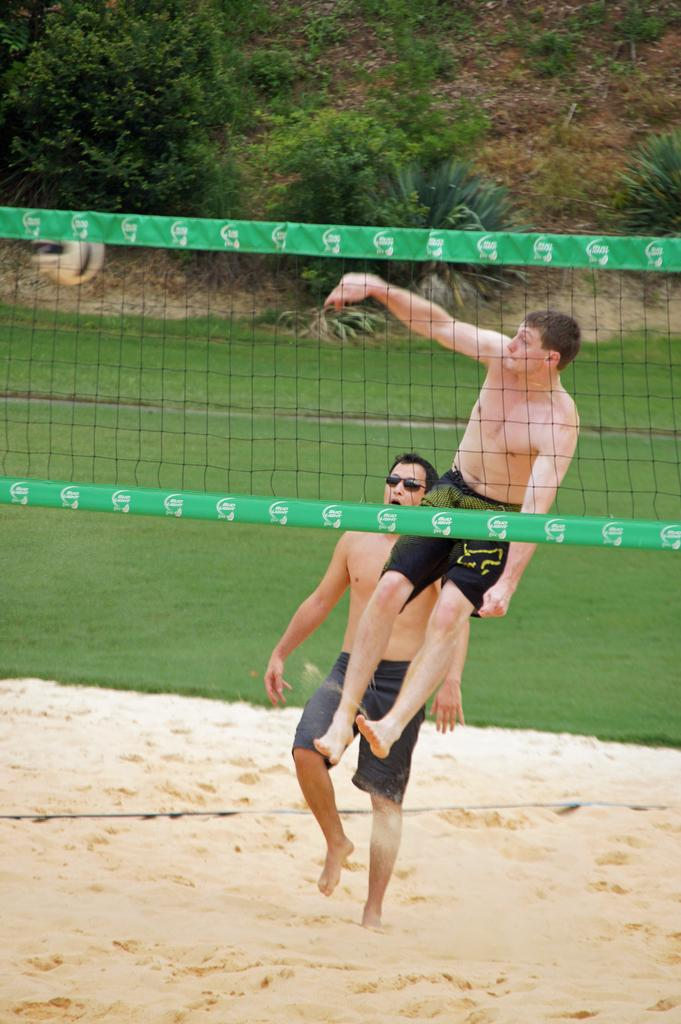How many people are in the image? There are people in the image, but the exact number is not specified. What is one person doing in the image? One person is jumping in the image. What can be seen in the background of the image? There are trees in the background of the image. What is the purpose of the net visible in the image? The net may be used for sports or recreational activities, but its specific purpose is not mentioned. What is the ground made of in the image? The ground is present at the bottom of the image, and it is made of sand. Can you see any smoke coming from the jellyfish in the image? There is no jellyfish or smoke present in the image. What type of mark is visible on the person's forehead in the image? There is no mention of any mark on a person's forehead in the image. 